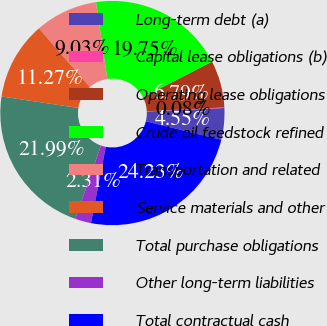<chart> <loc_0><loc_0><loc_500><loc_500><pie_chart><fcel>Long-term debt (a)<fcel>Capital lease obligations (b)<fcel>Operating lease obligations<fcel>Crude oil feedstock refined<fcel>Transportation and related<fcel>Service materials and other<fcel>Total purchase obligations<fcel>Other long-term liabilities<fcel>Total contractual cash<nl><fcel>4.55%<fcel>0.08%<fcel>6.79%<fcel>19.75%<fcel>9.03%<fcel>11.27%<fcel>21.99%<fcel>2.31%<fcel>24.23%<nl></chart> 